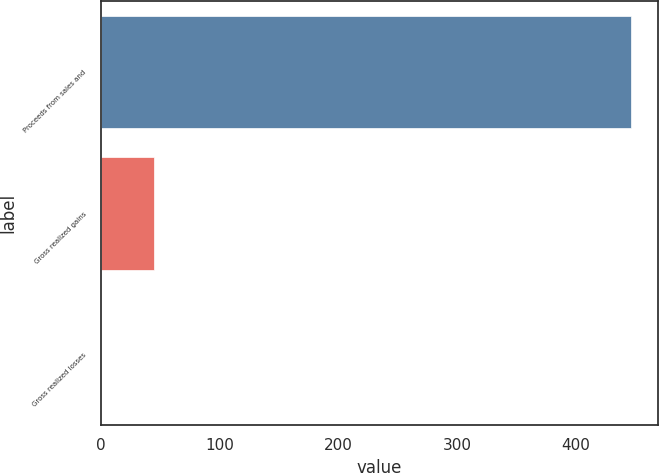Convert chart to OTSL. <chart><loc_0><loc_0><loc_500><loc_500><bar_chart><fcel>Proceeds from sales and<fcel>Gross realized gains<fcel>Gross realized losses<nl><fcel>446.4<fcel>45<fcel>0.4<nl></chart> 